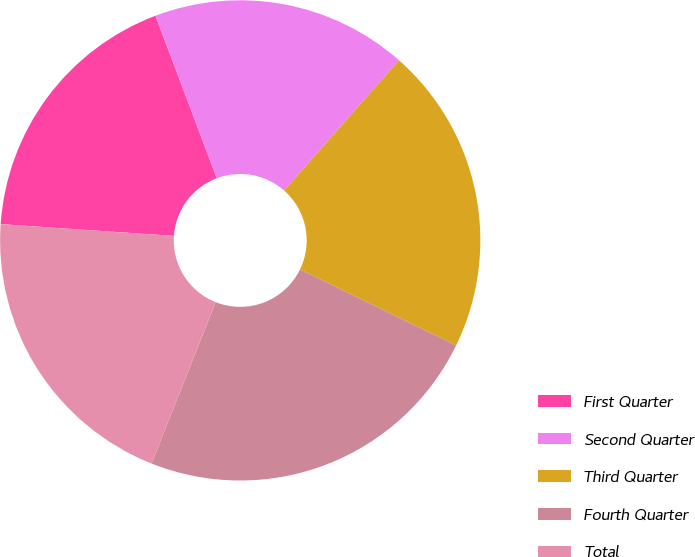<chart> <loc_0><loc_0><loc_500><loc_500><pie_chart><fcel>First Quarter<fcel>Second Quarter<fcel>Third Quarter<fcel>Fourth Quarter<fcel>Total<nl><fcel>18.18%<fcel>17.24%<fcel>20.71%<fcel>23.82%<fcel>20.06%<nl></chart> 